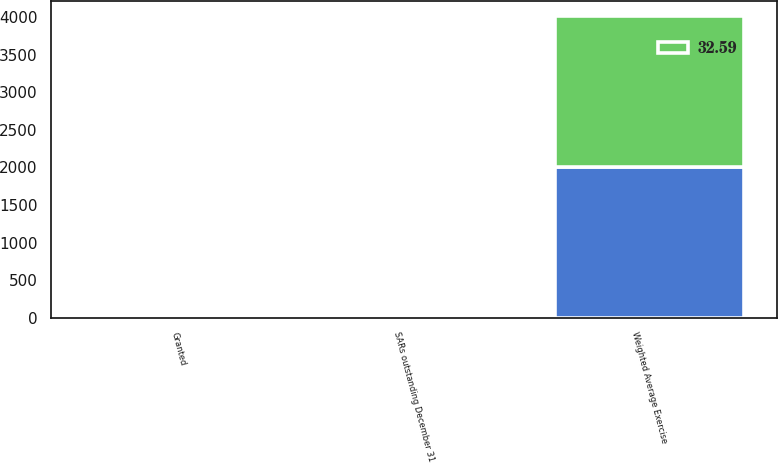Convert chart. <chart><loc_0><loc_0><loc_500><loc_500><stacked_bar_chart><ecel><fcel>Weighted Average Exercise<fcel>Granted<fcel>SARs outstanding December 31<nl><fcel>32.59<fcel>2007<fcel>44.97<fcel>38.85<nl><fcel>nan<fcel>2006<fcel>32.59<fcel>32.59<nl></chart> 